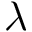Convert formula to latex. <formula><loc_0><loc_0><loc_500><loc_500>\lambda</formula> 